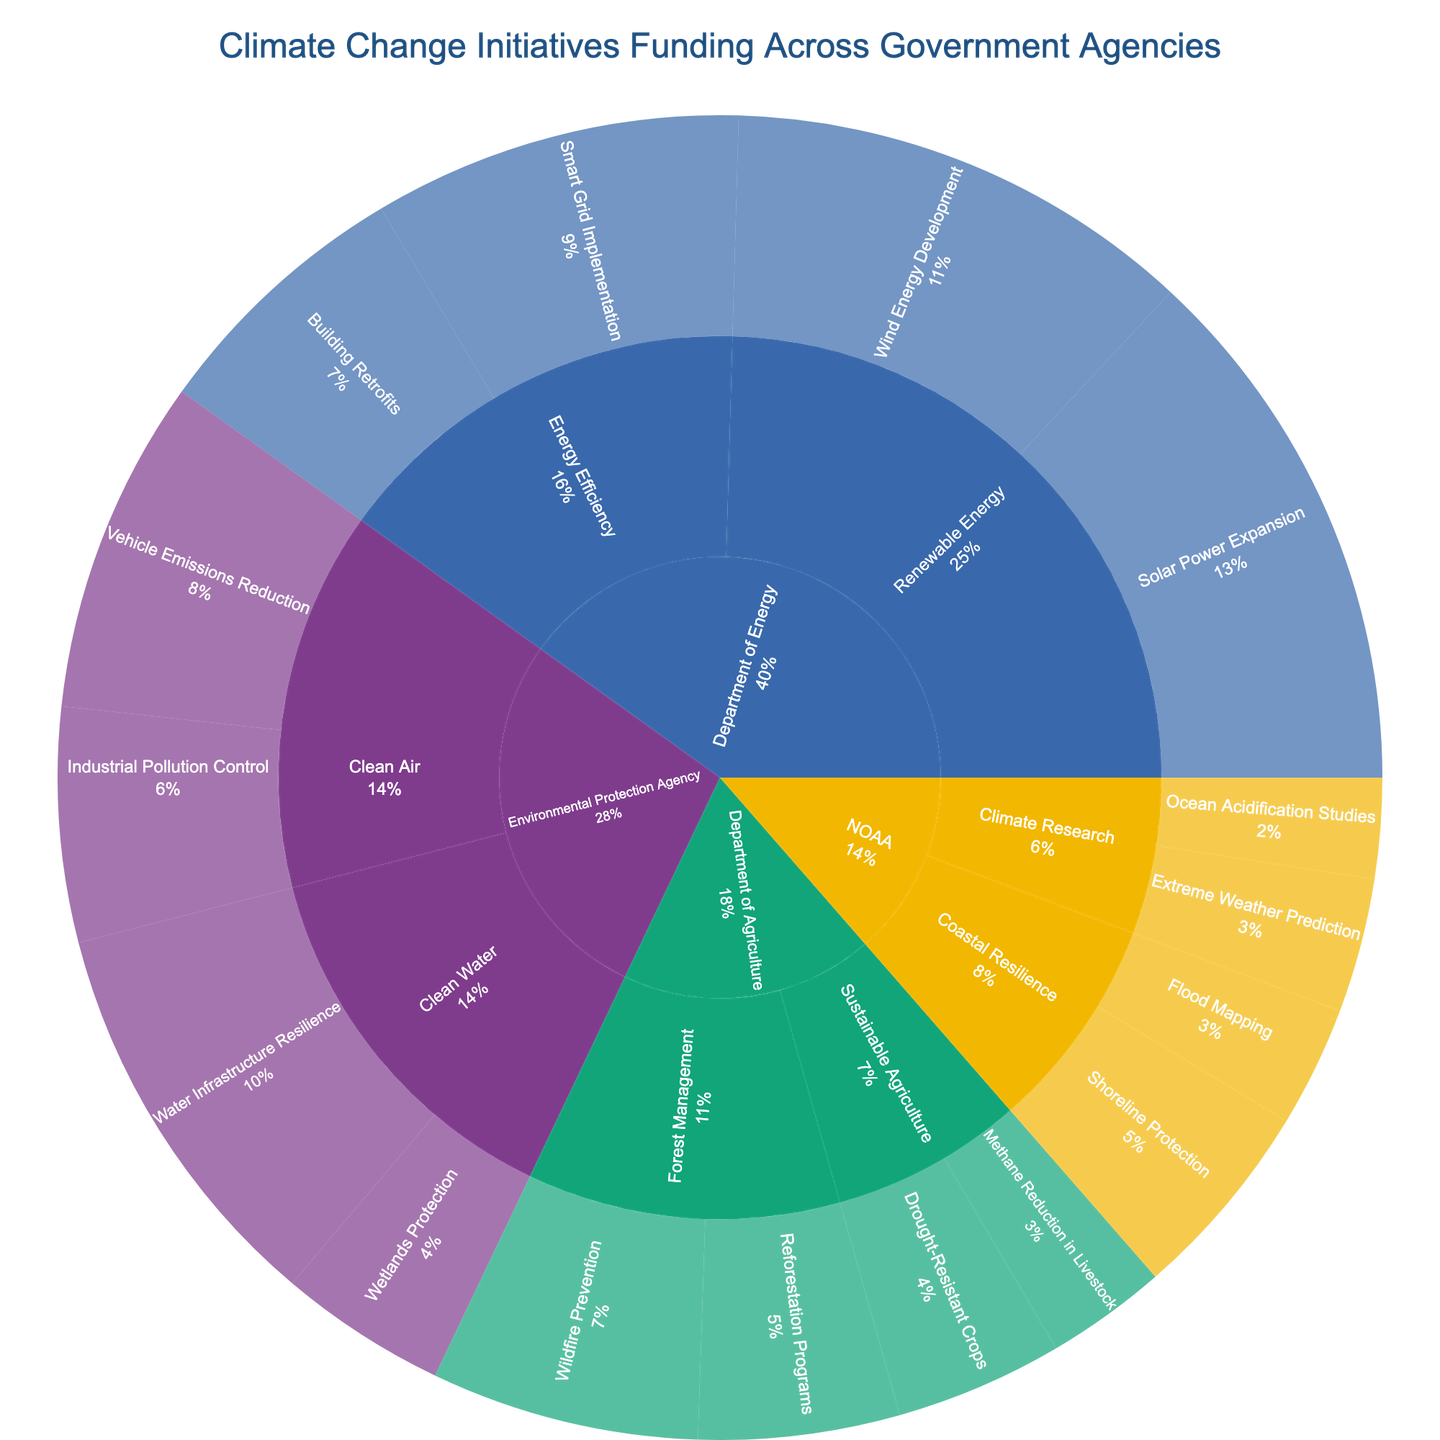What's the title of the figure? The title is typically located at the top of the figure and describes the main topic represented.
Answer: Climate Change Initiatives Funding Across Government Agencies Which government agency has the highest total funding for climate change initiatives? By looking at the sizes of the slices for each agency, the Department of Energy has the largest segments overall, indicating it has the highest total funding.
Answer: Department of Energy What is the total funding for the "Clean Air" initiatives under the Environmental Protection Agency? Sum the funding values for "Vehicle Emissions Reduction" and "Industrial Pollution Control": $500,000,000 + $350,000,000.
Answer: $850,000,000 Which initiative within the Department of Agriculture has the largest funding? Within the Department of Agriculture, the largest segment among the initiatives is "Wildfire Prevention" under "Forest Management".
Answer: Wildfire Prevention How much more funding does the "Solar Power Expansion" initiative have compared to the "Wind Energy Development" initiative? Subtract the funding for "Wind Energy Development" from the funding for "Solar Power Expansion": $800,000,000 - $700,000,000.
Answer: $100,000,000 What percentage of the total funding is allocated to the "Renewable Energy" subcategory under the Department of Energy? Sum the funding for "Solar Power Expansion" and "Wind Energy Development" to get the "Renewable Energy" total: $800,000,000 + $700,000,000 = $1,500,000,000. Compare this to the total funding represented in the figure (all segments summed).
Answer: ~16.7% Which subcategory within NOAA has the least funding? Among the subcategories under NOAA, "Climate Research" contains the "Ocean Acidification Studies" and "Extreme Weather Prediction" initiatives. "Coastal Resilience" contains "Shoreline Protection" and "Flood Mapping". The smaller segments belong to "Coastal Resilience".
Answer: Coastal Resilience How does the funding for "Vehicle Emissions Reduction" compare to "Building Retrofits"? By comparing the sizes of segments for these initiatives, "Vehicle Emissions Reduction" under the Environmental Protection Agency is larger than "Building Retrofits" under the Department of Energy.
Answer: Greater What are the primary subcategories receiving funding under the Department of Agriculture? The Department of Agriculture shows three main subcategories in the sunburst plot: "Sustainable Agriculture," "Forest Management," and their corresponding initiatives.
Answer: Sustainable Agriculture, Forest Management How much funding in total does NOAA receive for climate change initiatives? Sum the funding values for all initiatives under NOAA: $150,000,000 + $200,000,000 + $300,000,000 + $180,000,000.
Answer: $830,000,000 